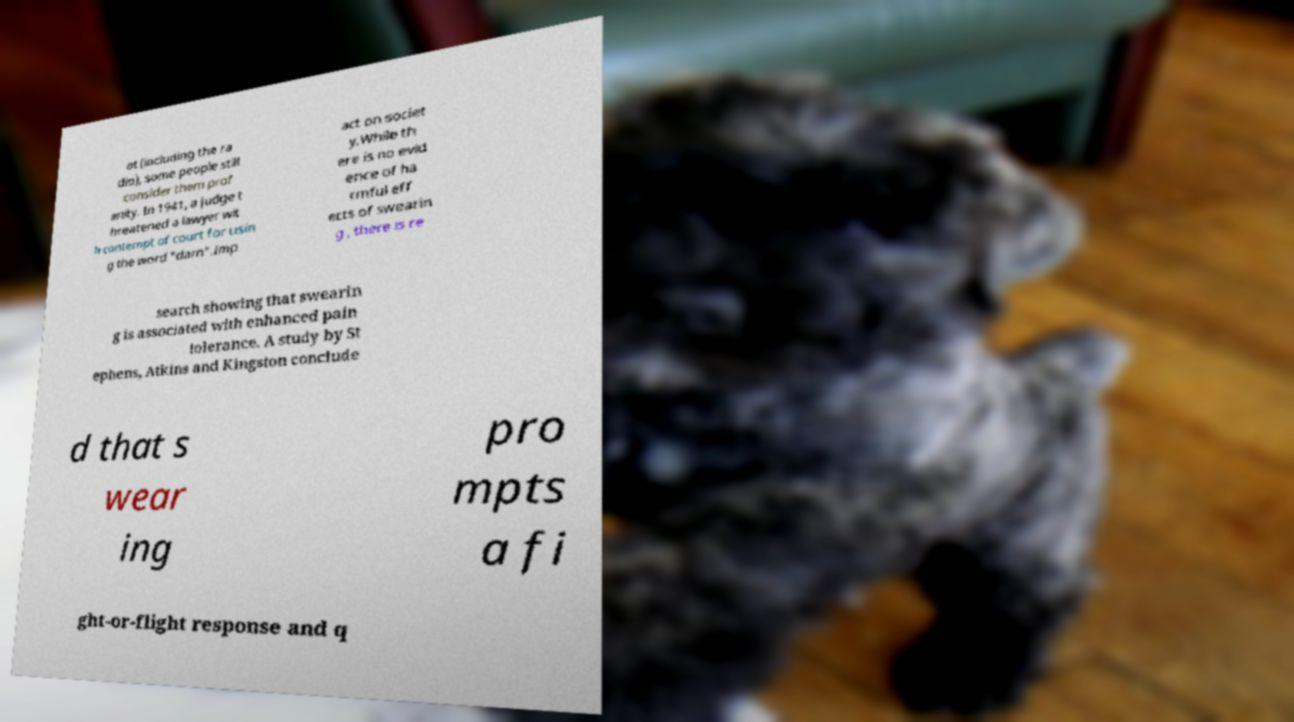Can you read and provide the text displayed in the image?This photo seems to have some interesting text. Can you extract and type it out for me? ot (including the ra dio), some people still consider them prof anity. In 1941, a judge t hreatened a lawyer wit h contempt of court for usin g the word "darn".Imp act on societ y.While th ere is no evid ence of ha rmful eff ects of swearin g , there is re search showing that swearin g is associated with enhanced pain tolerance. A study by St ephens, Atkins and Kingston conclude d that s wear ing pro mpts a fi ght-or-flight response and q 